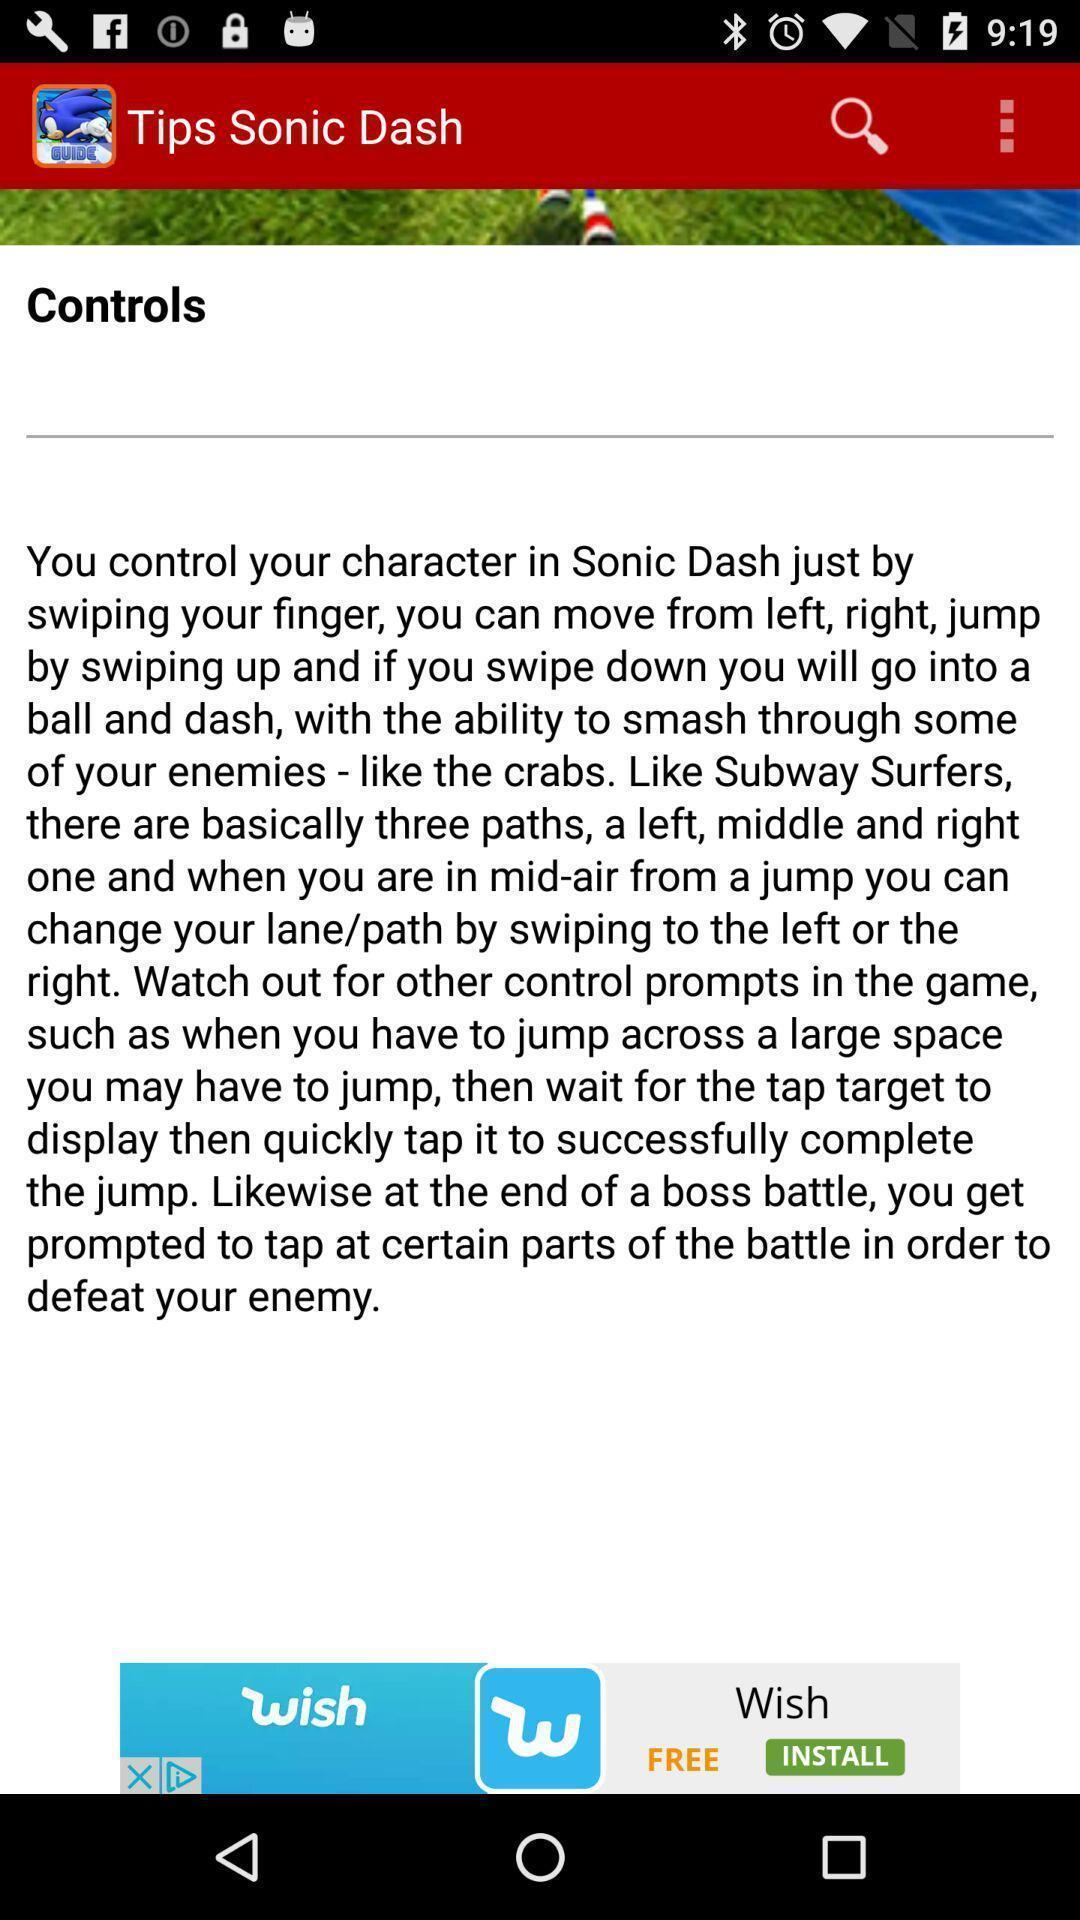Provide a description of this screenshot. Page showing controls of a game. 